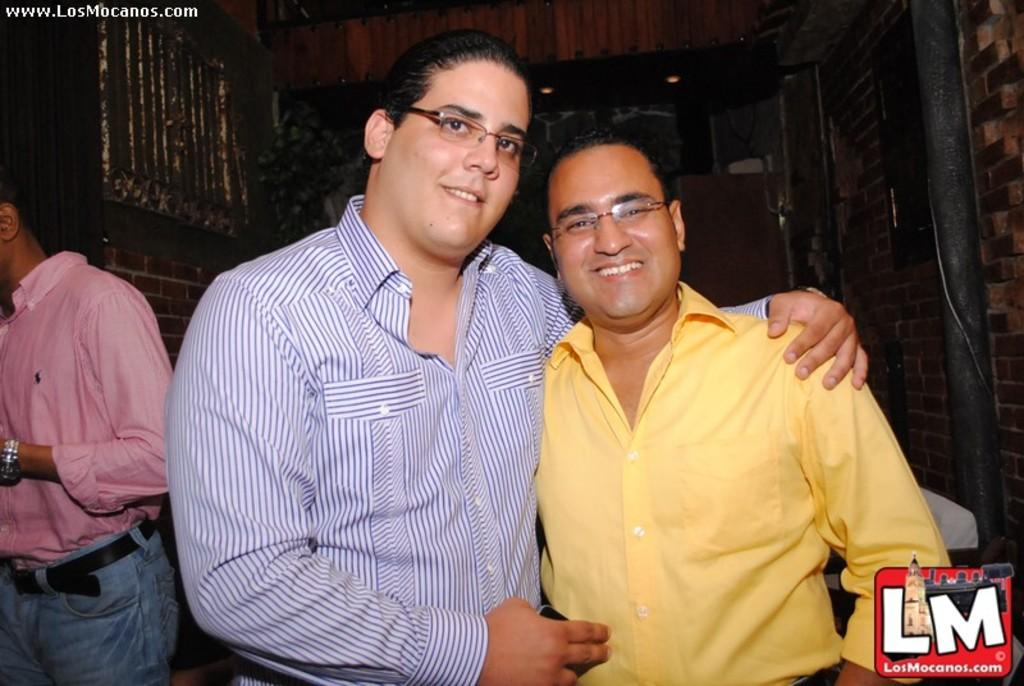What is the expression on the faces of the people in the image? Two people are smiling in the image. Can you describe any additional features of the image? There is a watermark in the corner of the image. What is the man wearing in the image? A man is wearing a pink shirt in the image. What type of wall can be seen in the image? The wall in the image has bricks. How much debt does the shelf in the image have? There is no shelf present in the image, so it is not possible to determine any debt associated with it. 